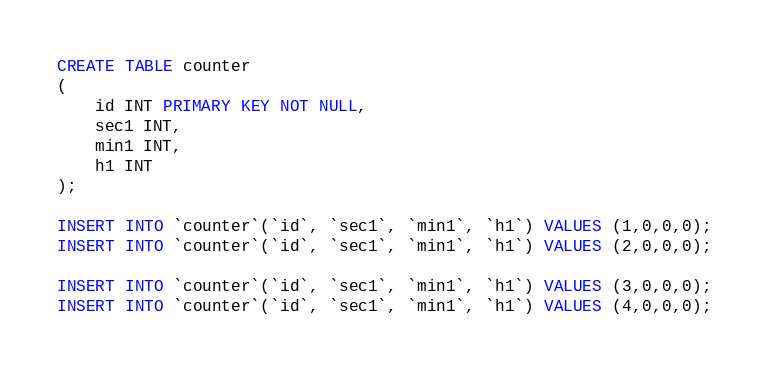Convert code to text. <code><loc_0><loc_0><loc_500><loc_500><_SQL_>CREATE TABLE counter
(
    id INT PRIMARY KEY NOT NULL,
    sec1 INT,
    min1 INT,
    h1 INT
);

INSERT INTO `counter`(`id`, `sec1`, `min1`, `h1`) VALUES (1,0,0,0);
INSERT INTO `counter`(`id`, `sec1`, `min1`, `h1`) VALUES (2,0,0,0);

INSERT INTO `counter`(`id`, `sec1`, `min1`, `h1`) VALUES (3,0,0,0);
INSERT INTO `counter`(`id`, `sec1`, `min1`, `h1`) VALUES (4,0,0,0);</code> 